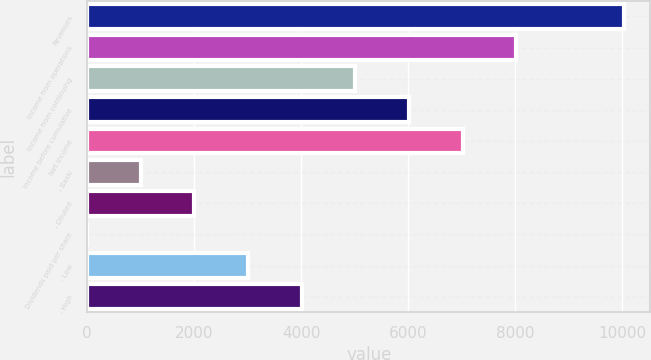Convert chart to OTSL. <chart><loc_0><loc_0><loc_500><loc_500><bar_chart><fcel>Revenues<fcel>Income from operations<fcel>Income from continuing<fcel>Income before cumulative<fcel>Net income<fcel>- Basic<fcel>- Diluted<fcel>Dividends paid per share<fcel>- Low<fcel>- High<nl><fcel>10032<fcel>8025.67<fcel>5016.13<fcel>6019.31<fcel>7022.49<fcel>1003.41<fcel>2006.59<fcel>0.23<fcel>3009.77<fcel>4012.95<nl></chart> 